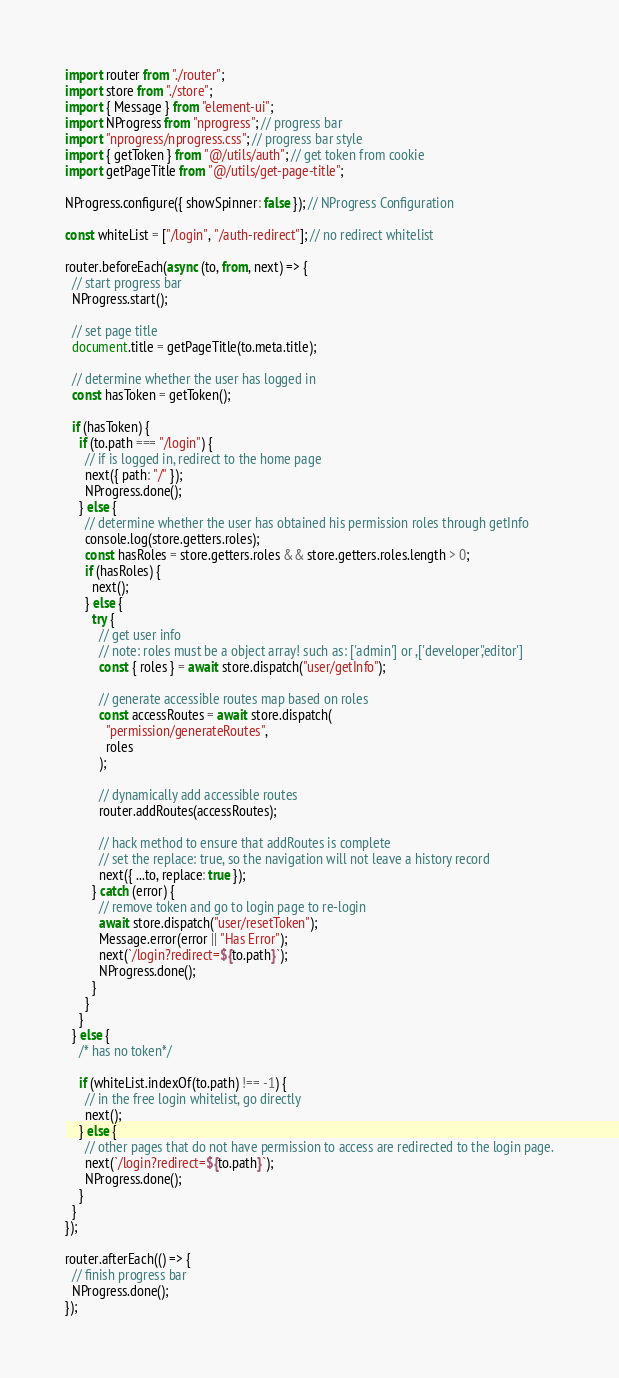Convert code to text. <code><loc_0><loc_0><loc_500><loc_500><_JavaScript_>import router from "./router";
import store from "./store";
import { Message } from "element-ui";
import NProgress from "nprogress"; // progress bar
import "nprogress/nprogress.css"; // progress bar style
import { getToken } from "@/utils/auth"; // get token from cookie
import getPageTitle from "@/utils/get-page-title";

NProgress.configure({ showSpinner: false }); // NProgress Configuration

const whiteList = ["/login", "/auth-redirect"]; // no redirect whitelist

router.beforeEach(async (to, from, next) => {
  // start progress bar
  NProgress.start();

  // set page title
  document.title = getPageTitle(to.meta.title);

  // determine whether the user has logged in
  const hasToken = getToken();

  if (hasToken) {
    if (to.path === "/login") {
      // if is logged in, redirect to the home page
      next({ path: "/" });
      NProgress.done();
    } else {
      // determine whether the user has obtained his permission roles through getInfo
      console.log(store.getters.roles);
      const hasRoles = store.getters.roles && store.getters.roles.length > 0;
      if (hasRoles) {
        next();
      } else {
        try {
          // get user info
          // note: roles must be a object array! such as: ['admin'] or ,['developer','editor']
          const { roles } = await store.dispatch("user/getInfo");

          // generate accessible routes map based on roles
          const accessRoutes = await store.dispatch(
            "permission/generateRoutes",
            roles
          );

          // dynamically add accessible routes
          router.addRoutes(accessRoutes);

          // hack method to ensure that addRoutes is complete
          // set the replace: true, so the navigation will not leave a history record
          next({ ...to, replace: true });
        } catch (error) {
          // remove token and go to login page to re-login
          await store.dispatch("user/resetToken");
          Message.error(error || "Has Error");
          next(`/login?redirect=${to.path}`);
          NProgress.done();
        }
      }
    }
  } else {
    /* has no token*/

    if (whiteList.indexOf(to.path) !== -1) {
      // in the free login whitelist, go directly
      next();
    } else {
      // other pages that do not have permission to access are redirected to the login page.
      next(`/login?redirect=${to.path}`);
      NProgress.done();
    }
  }
});

router.afterEach(() => {
  // finish progress bar
  NProgress.done();
});
</code> 